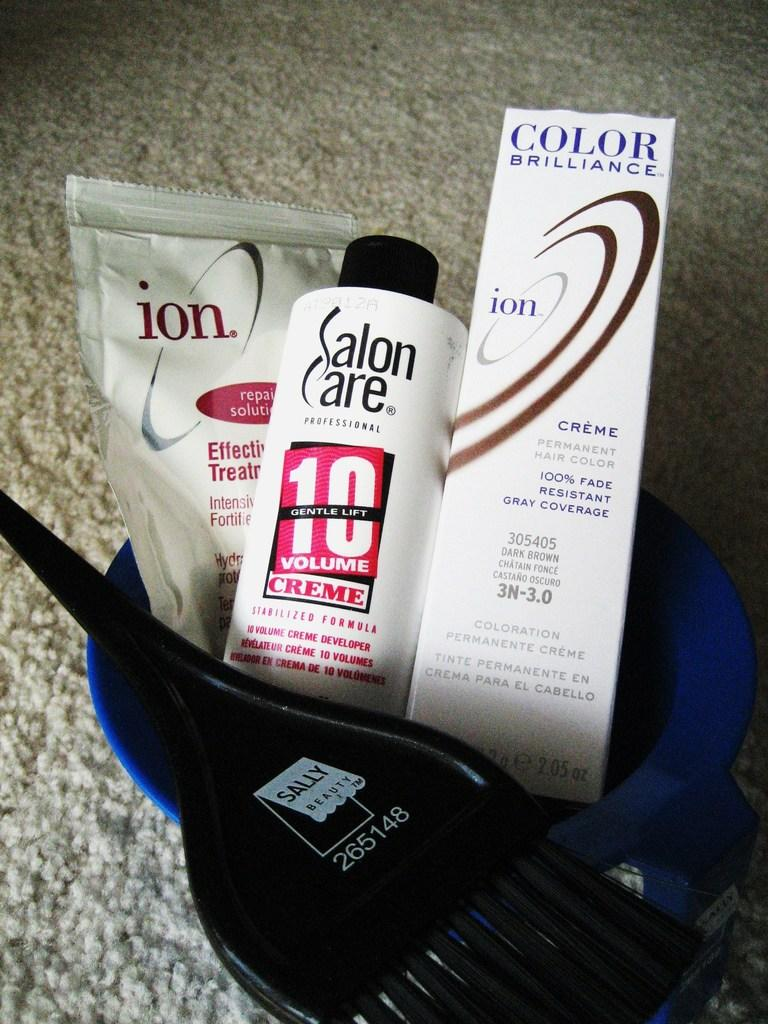What type of items can be seen in the image? There are cosmetics, a brush, and a bowl in the image. What might be used for applying or blending the cosmetics? The brush in the image can be used for applying or blending the cosmetics. Where are the cosmetics, brush, and bowl placed? They are placed on a mat in the image. What type of card is being used to mix the cosmetics in the image? There is no card present in the image; the items mentioned are cosmetics, a brush, and a bowl. 